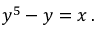Convert formula to latex. <formula><loc_0><loc_0><loc_500><loc_500>y ^ { 5 } - y = x \, .</formula> 